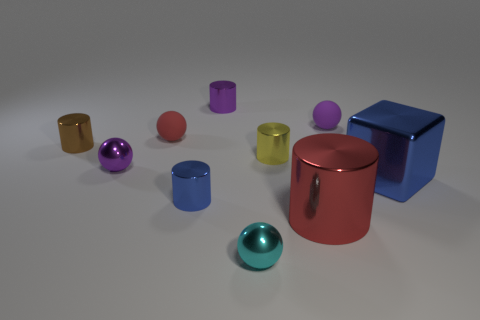There is a red thing that is on the right side of the tiny yellow metal cylinder; does it have the same shape as the blue object that is to the left of the blue block?
Offer a terse response. Yes. How many objects are either tiny purple metallic things or cylinders that are behind the red metallic thing?
Give a very brief answer. 5. There is a object that is the same color as the big cylinder; what shape is it?
Offer a terse response. Sphere. What number of shiny things have the same size as the purple matte ball?
Provide a short and direct response. 6. What number of red objects are large cubes or tiny matte spheres?
Your response must be concise. 1. There is a purple object that is behind the small purple ball that is to the right of the blue cylinder; what shape is it?
Offer a very short reply. Cylinder. What shape is the red metal thing that is the same size as the blue cube?
Provide a short and direct response. Cylinder. Is there another metal cylinder that has the same color as the large cylinder?
Keep it short and to the point. No. Are there the same number of small purple metallic things that are in front of the yellow thing and tiny yellow cylinders that are to the left of the small purple cylinder?
Offer a very short reply. No. There is a tiny red matte object; is it the same shape as the blue object on the left side of the red cylinder?
Your answer should be very brief. No. 